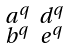<formula> <loc_0><loc_0><loc_500><loc_500>\begin{smallmatrix} a ^ { q } & d ^ { q } \\ b ^ { q } & e ^ { q } \end{smallmatrix}</formula> 